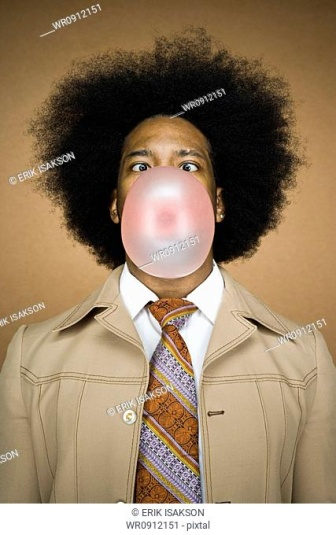Imagine this image is the cover of a magazine. Write the headline and a short tagline that captivates the reader's attention. Headline: 'Retro Revival: Embrace Your Quirky Side!'
Tagline: 'Step into a world where style meets fun, and bubble gum is the accessory that never goes out of fashion. Discover the playful essence of vintage flair in modern times.' 